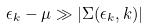Convert formula to latex. <formula><loc_0><loc_0><loc_500><loc_500>\epsilon _ { k } - \mu \gg | \Sigma ( \epsilon _ { k } , { k } ) |</formula> 